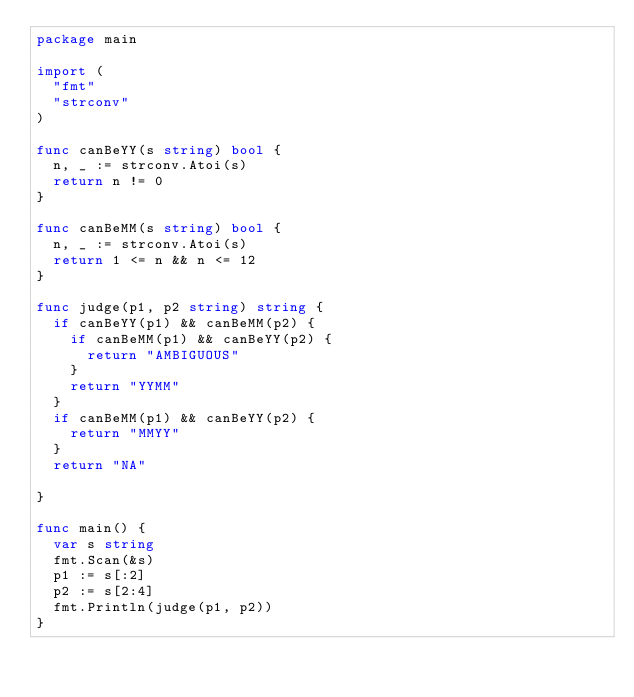Convert code to text. <code><loc_0><loc_0><loc_500><loc_500><_Go_>package main

import (
	"fmt"
	"strconv"
)

func canBeYY(s string) bool {
	n, _ := strconv.Atoi(s)
	return n != 0
}

func canBeMM(s string) bool {
	n, _ := strconv.Atoi(s)
	return 1 <= n && n <= 12
}

func judge(p1, p2 string) string {
	if canBeYY(p1) && canBeMM(p2) {
		if canBeMM(p1) && canBeYY(p2) {
			return "AMBIGUOUS"
		}
		return "YYMM"
	}
	if canBeMM(p1) && canBeYY(p2) {
		return "MMYY"
	}
	return "NA"

}

func main() {
	var s string
	fmt.Scan(&s)
	p1 := s[:2]
	p2 := s[2:4]
	fmt.Println(judge(p1, p2))
}
</code> 